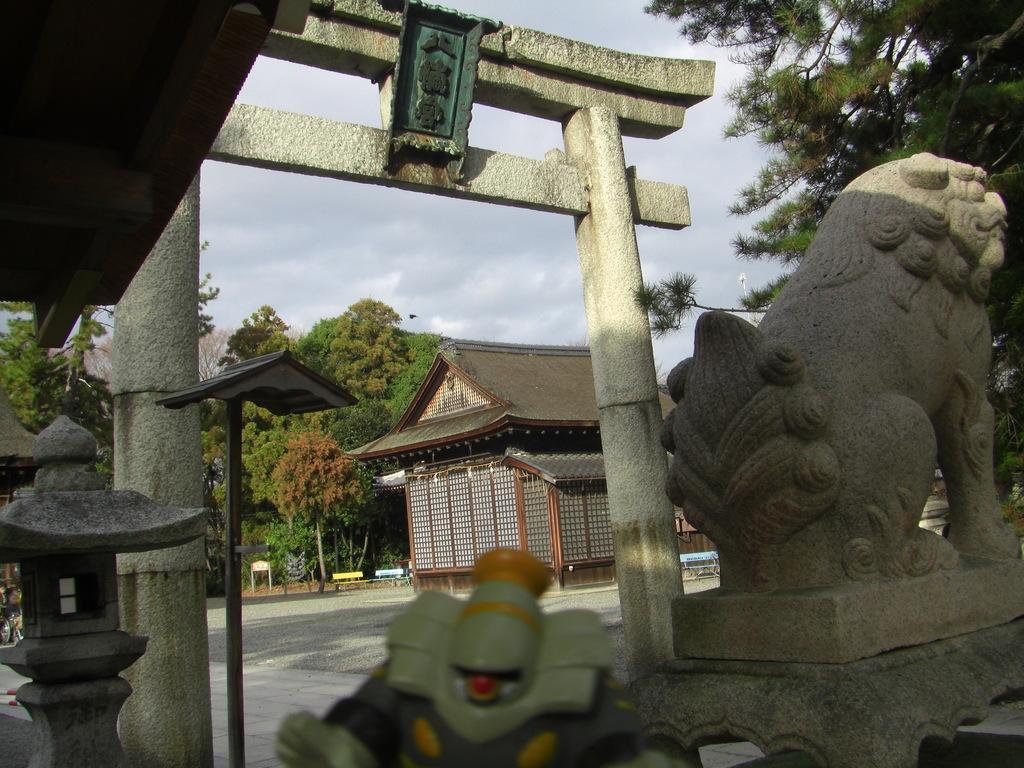How would you summarize this image in a sentence or two? In this image there is a statue on the right side and there is a arch beside it. In the middle there is a house and there are trees around it. At the top there is sky. 